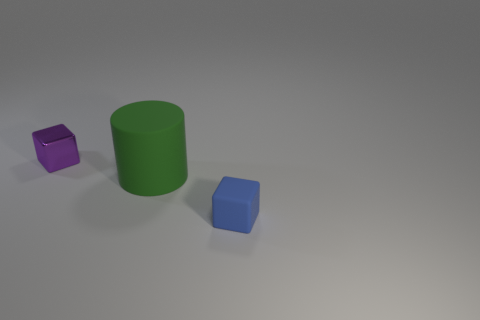Add 3 tiny rubber cubes. How many objects exist? 6 Subtract all cylinders. How many objects are left? 2 Add 3 big green objects. How many big green objects are left? 4 Add 2 metal cubes. How many metal cubes exist? 3 Subtract 0 brown cylinders. How many objects are left? 3 Subtract all green matte things. Subtract all brown shiny cylinders. How many objects are left? 2 